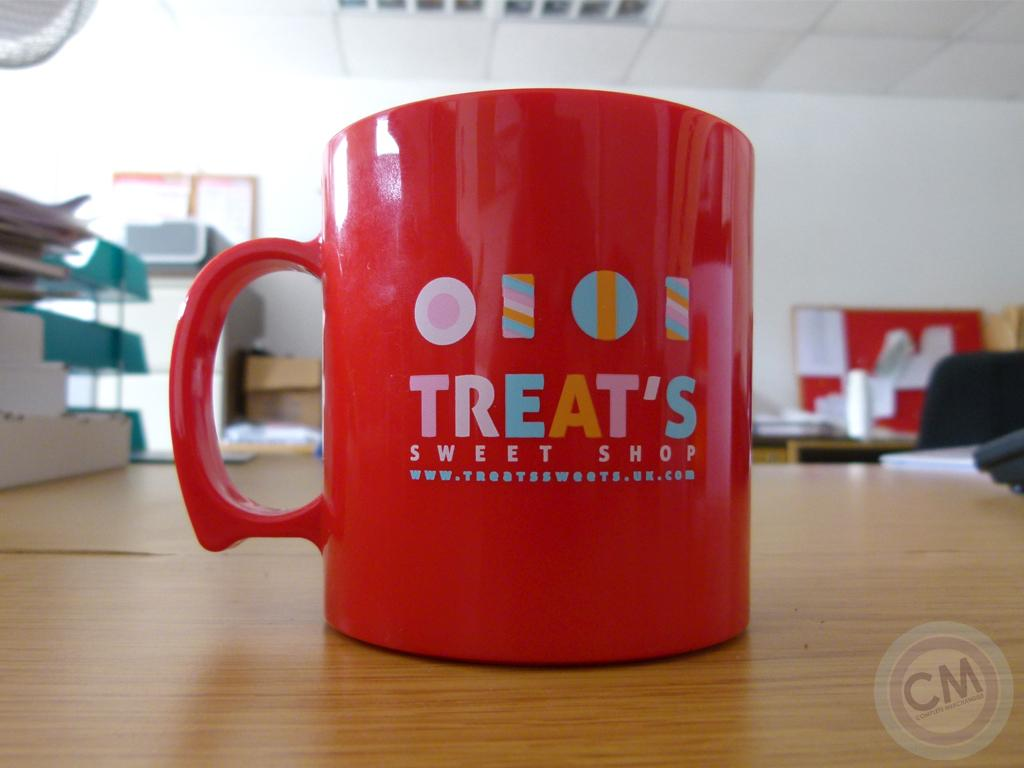Provide a one-sentence caption for the provided image. A red mug from Treat's Sweet Shop sits alone on a large wooden topped table. 